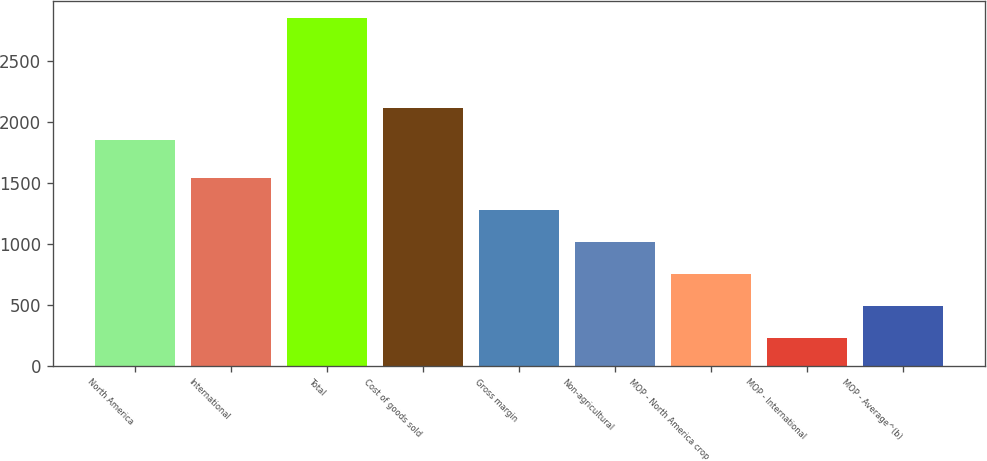Convert chart. <chart><loc_0><loc_0><loc_500><loc_500><bar_chart><fcel>North America<fcel>International<fcel>Total<fcel>Cost of goods sold<fcel>Gross margin<fcel>Non-agricultural<fcel>MOP - North America crop<fcel>MOP - International<fcel>MOP - Average^(b)<nl><fcel>1850.2<fcel>1538.8<fcel>2851.6<fcel>2112.76<fcel>1276.24<fcel>1013.68<fcel>751.12<fcel>226<fcel>488.56<nl></chart> 